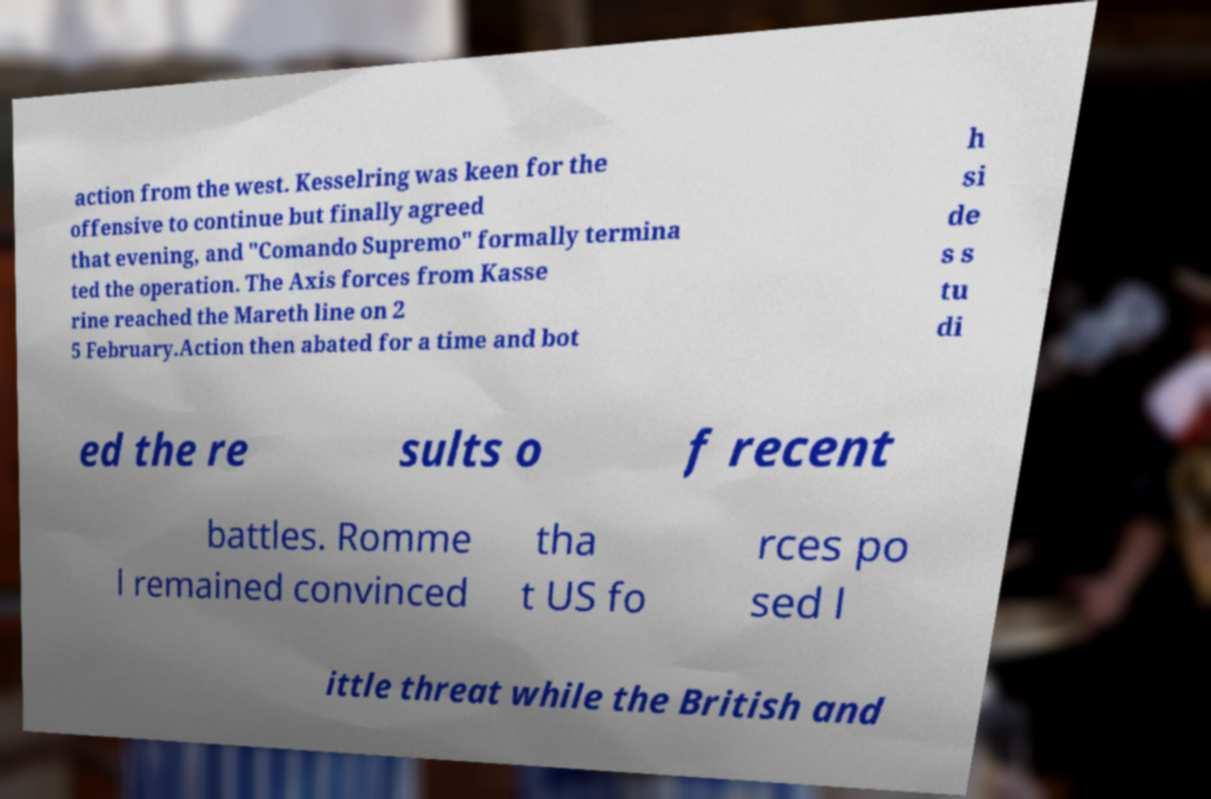I need the written content from this picture converted into text. Can you do that? action from the west. Kesselring was keen for the offensive to continue but finally agreed that evening, and "Comando Supremo" formally termina ted the operation. The Axis forces from Kasse rine reached the Mareth line on 2 5 February.Action then abated for a time and bot h si de s s tu di ed the re sults o f recent battles. Romme l remained convinced tha t US fo rces po sed l ittle threat while the British and 